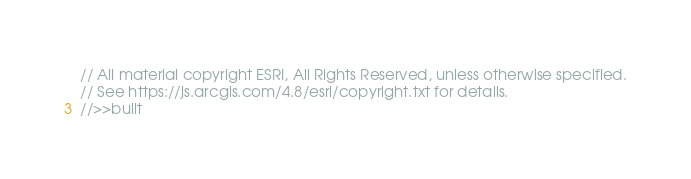Convert code to text. <code><loc_0><loc_0><loc_500><loc_500><_JavaScript_>// All material copyright ESRI, All Rights Reserved, unless otherwise specified.
// See https://js.arcgis.com/4.8/esri/copyright.txt for details.
//>>built</code> 